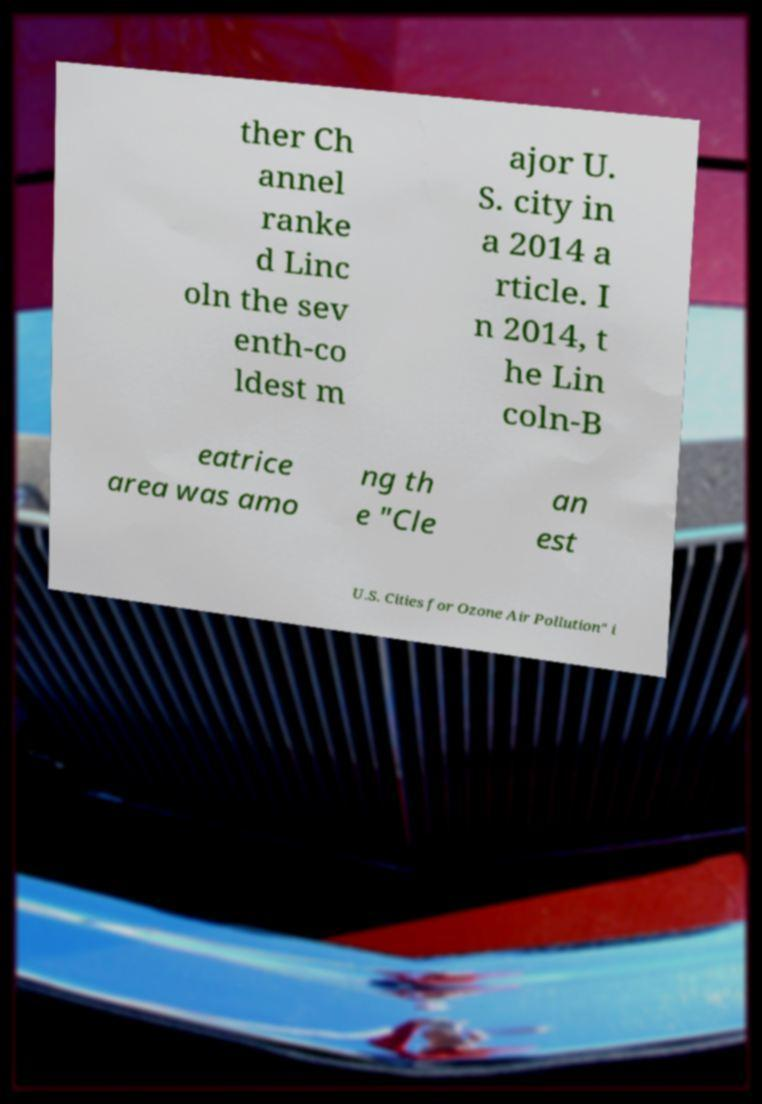There's text embedded in this image that I need extracted. Can you transcribe it verbatim? ther Ch annel ranke d Linc oln the sev enth-co ldest m ajor U. S. city in a 2014 a rticle. I n 2014, t he Lin coln-B eatrice area was amo ng th e "Cle an est U.S. Cities for Ozone Air Pollution" i 